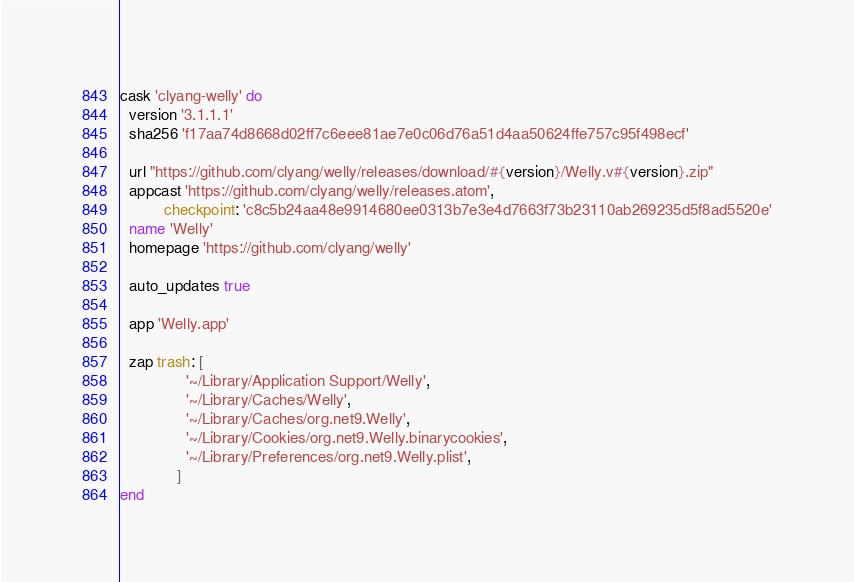Convert code to text. <code><loc_0><loc_0><loc_500><loc_500><_Ruby_>cask 'clyang-welly' do
  version '3.1.1.1'
  sha256 'f17aa74d8668d02ff7c6eee81ae7e0c06d76a51d4aa50624ffe757c95f498ecf'

  url "https://github.com/clyang/welly/releases/download/#{version}/Welly.v#{version}.zip"
  appcast 'https://github.com/clyang/welly/releases.atom',
          checkpoint: 'c8c5b24aa48e9914680ee0313b7e3e4d7663f73b23110ab269235d5f8ad5520e'
  name 'Welly'
  homepage 'https://github.com/clyang/welly'

  auto_updates true

  app 'Welly.app'

  zap trash: [
               '~/Library/Application Support/Welly',
               '~/Library/Caches/Welly',
               '~/Library/Caches/org.net9.Welly',
               '~/Library/Cookies/org.net9.Welly.binarycookies',
               '~/Library/Preferences/org.net9.Welly.plist',
             ]
end
</code> 